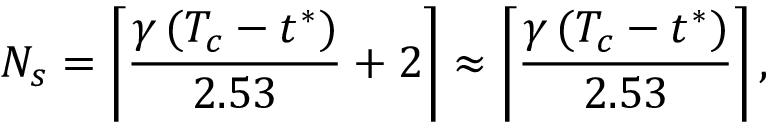Convert formula to latex. <formula><loc_0><loc_0><loc_500><loc_500>N _ { s } = \left \lceil \frac { \gamma \, ( T _ { c } - t ^ { * } ) } { 2 . 5 3 } + 2 \right \rceil \approx \left \lceil \frac { \gamma \, ( T _ { c } - t ^ { * } ) } { 2 . 5 3 } \right \rceil ,</formula> 